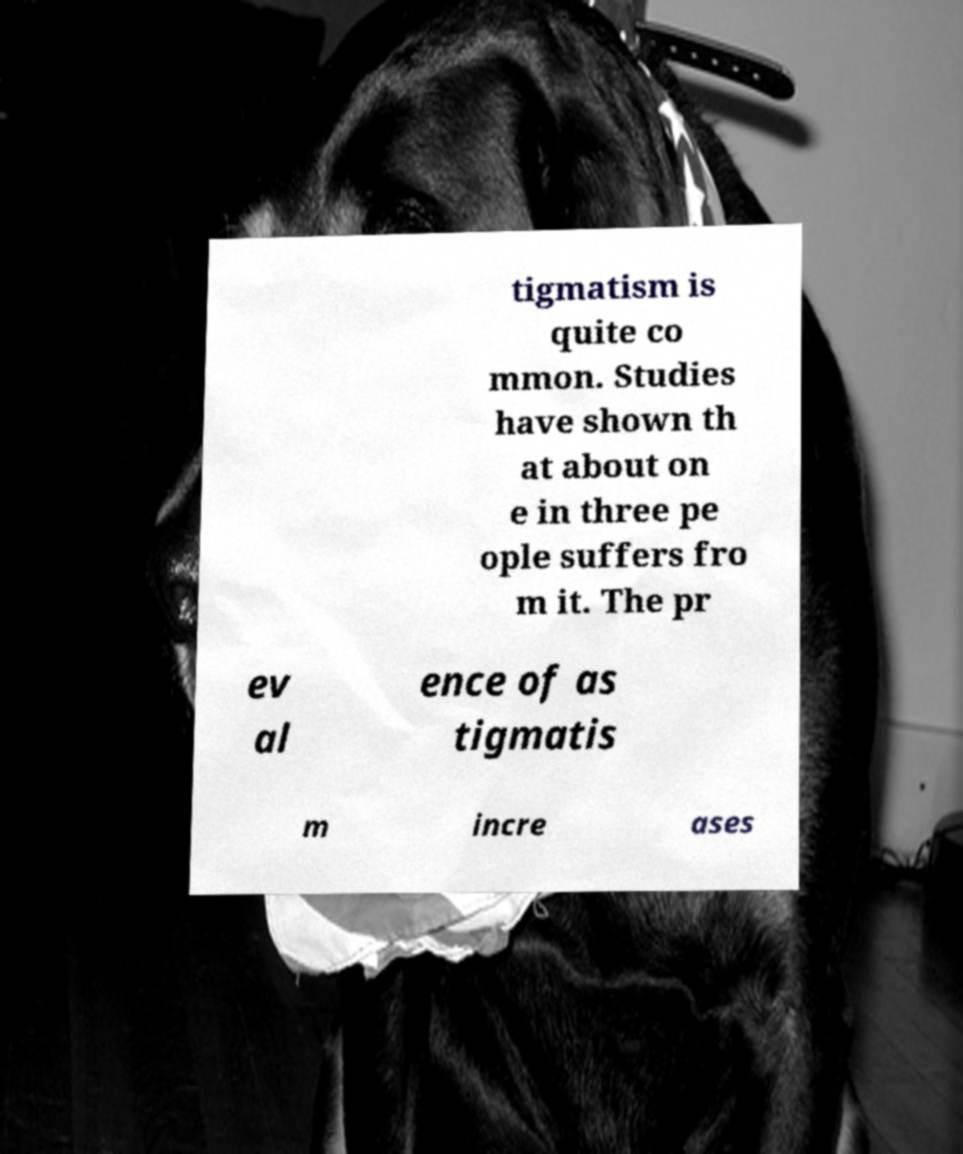Can you read and provide the text displayed in the image?This photo seems to have some interesting text. Can you extract and type it out for me? tigmatism is quite co mmon. Studies have shown th at about on e in three pe ople suffers fro m it. The pr ev al ence of as tigmatis m incre ases 